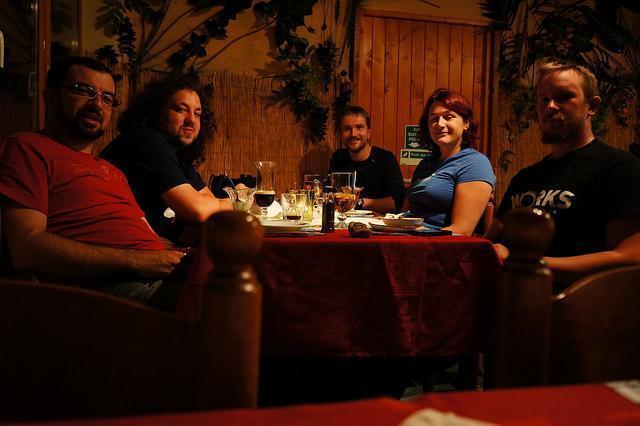How many men are photographed?
Give a very brief answer. 4. How many people are there?
Give a very brief answer. 5. How many dining tables are there?
Give a very brief answer. 2. How many chairs are there?
Give a very brief answer. 2. How many red cars can be seen to the right of the bus?
Give a very brief answer. 0. 